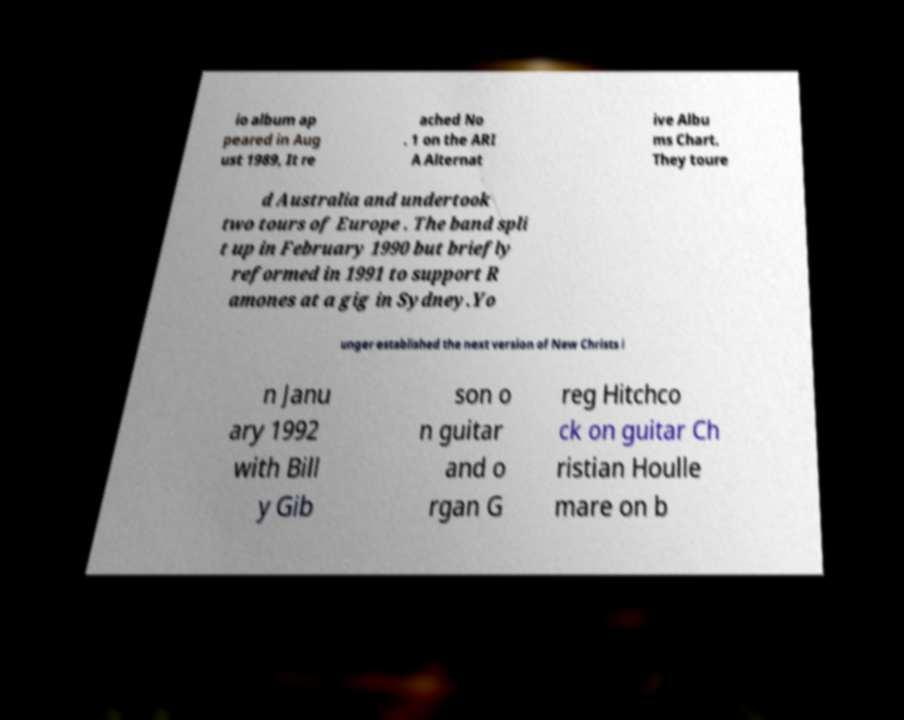Please identify and transcribe the text found in this image. io album ap peared in Aug ust 1989, It re ached No . 1 on the ARI A Alternat ive Albu ms Chart. They toure d Australia and undertook two tours of Europe . The band spli t up in February 1990 but briefly reformed in 1991 to support R amones at a gig in Sydney.Yo unger established the next version of New Christs i n Janu ary 1992 with Bill y Gib son o n guitar and o rgan G reg Hitchco ck on guitar Ch ristian Houlle mare on b 